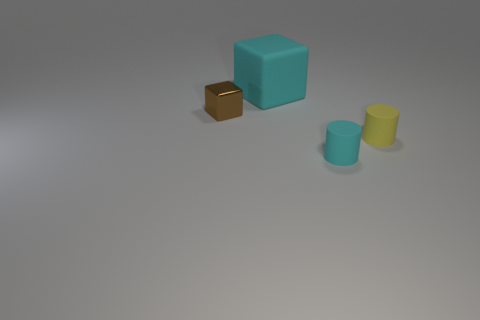Add 2 small rubber cylinders. How many objects exist? 6 Add 4 tiny cyan cylinders. How many tiny cyan cylinders are left? 5 Add 2 cyan metal spheres. How many cyan metal spheres exist? 2 Subtract 0 brown cylinders. How many objects are left? 4 Subtract all tiny blue matte cylinders. Subtract all cyan cylinders. How many objects are left? 3 